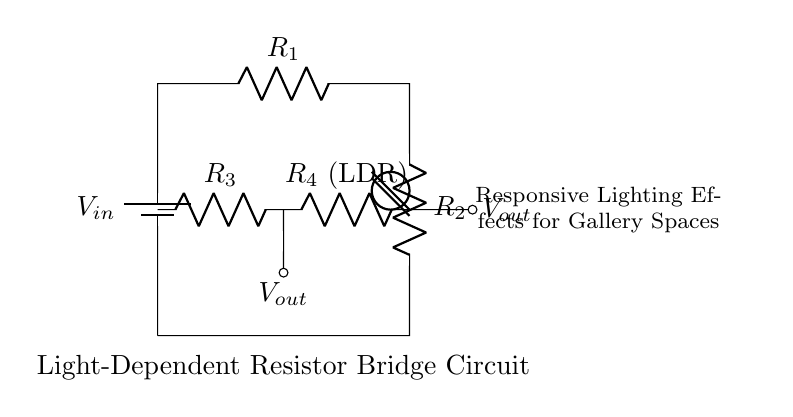What is the input voltage of the circuit? The input voltage is indicated by the label V_in next to the battery in the diagram. Since it is a bridge circuit, this voltage is typically the supply voltage feeding the resistors.
Answer: V_in What components are part of the bridge circuit? The components in the bridge circuit include two resistors R1 and R2, and two additional resistors R3 and R4, where R4 is a light-dependent resistor (LDR). This can be determined by looking at the components labeled in the diagram.
Answer: R1, R2, R3, R4 (LDR) What type of resistor is R4? R4 is designated as an LDR, which stands for light-dependent resistor, indicating that its resistance varies with the light intensity. This is clearly labeled next to R4 in the circuit diagram.
Answer: LDR What kind of effects can this circuit create in gallery spaces? The circuit is designed to create responsive lighting effects by adjusting the output voltage based on the light intensity detected by the LDR. The label in the diagram suggests that these changes can enhance the ambiance of the gallery space.
Answer: Responsive lighting effects How does the light intensity affect the output voltage? The output voltage V_out depends on the resistance of the LDR. As light intensity increases, the LDR's resistance decreases, which lowers the voltage across it in the bridge configuration, affecting the overall output voltage. This relationship can be deduced by understanding how resistances in a bridge affect voltage division.
Answer: Decreases output voltage What is the role of R1 and R2 in this circuit? Resistors R1 and R2 are part of the voltage divider that helps stabilize the bridge circuit's operation. Their resistances help determine the reference voltage against which the LDR's changing resistance is compared, aiding in creating a measurable output that changes based on illumination.
Answer: Stabilize the bridge 